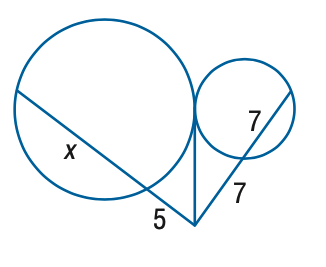Answer the mathemtical geometry problem and directly provide the correct option letter.
Question: Find the variable of x to the nearest tenth. Assume that segments that appear to be tangent are tangent.
Choices: A: 14.1 B: 14.6 C: 15.1 D: 15.6 B 